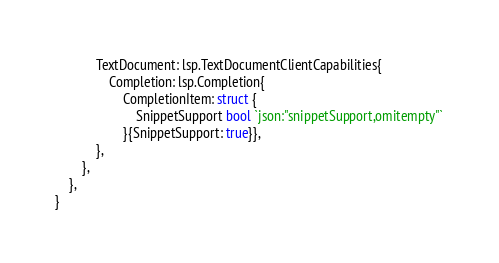<code> <loc_0><loc_0><loc_500><loc_500><_Go_>			TextDocument: lsp.TextDocumentClientCapabilities{
				Completion: lsp.Completion{
					CompletionItem: struct {
						SnippetSupport bool `json:"snippetSupport,omitempty"`
					}{SnippetSupport: true}},
			},
		},
	},
}
</code> 